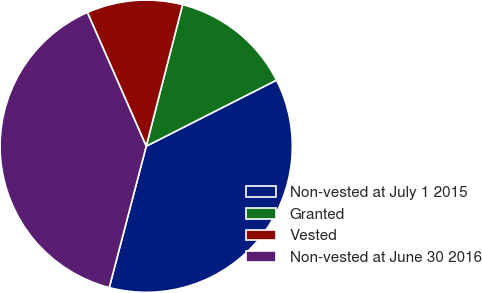<chart> <loc_0><loc_0><loc_500><loc_500><pie_chart><fcel>Non-vested at July 1 2015<fcel>Granted<fcel>Vested<fcel>Non-vested at June 30 2016<nl><fcel>36.54%<fcel>13.53%<fcel>10.6%<fcel>39.33%<nl></chart> 